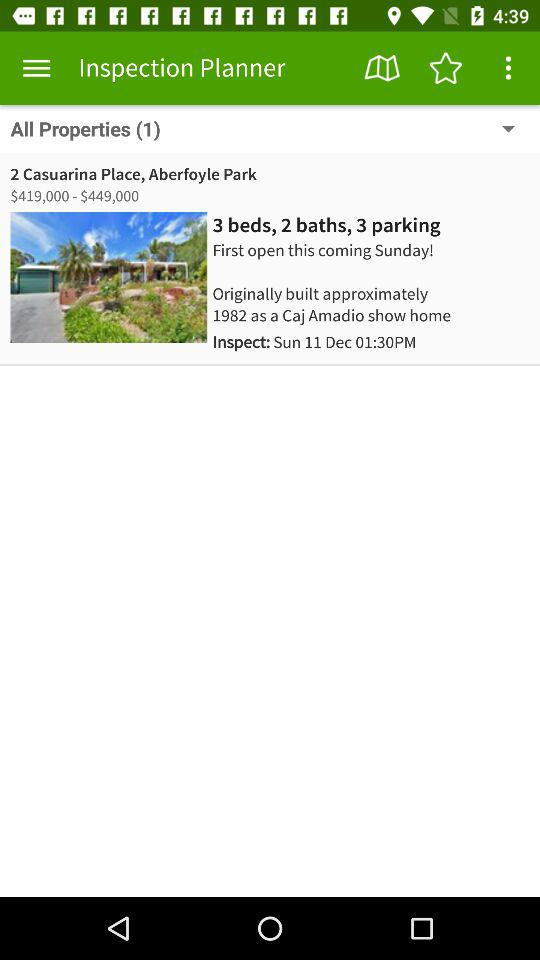How many more bedrooms does this property have than bathrooms?
Answer the question using a single word or phrase. 1 